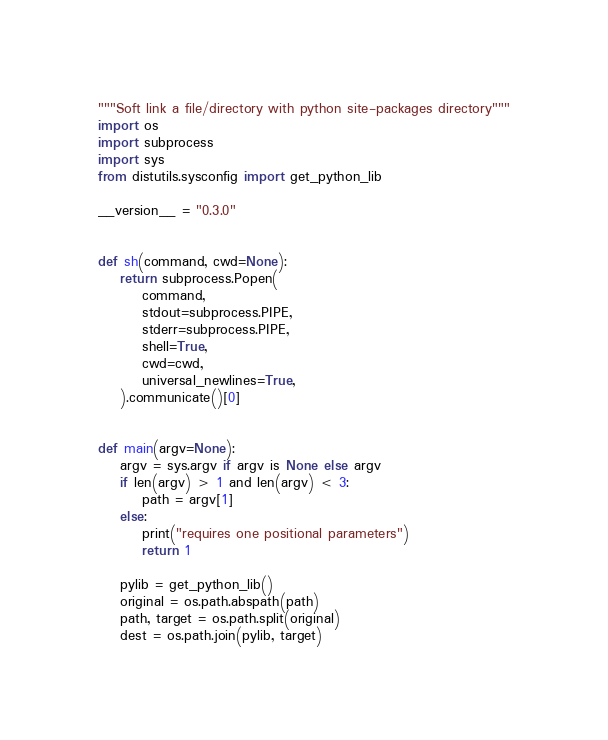<code> <loc_0><loc_0><loc_500><loc_500><_Python_>"""Soft link a file/directory with python site-packages directory"""
import os
import subprocess
import sys
from distutils.sysconfig import get_python_lib

__version__ = "0.3.0"


def sh(command, cwd=None):
    return subprocess.Popen(
        command,
        stdout=subprocess.PIPE,
        stderr=subprocess.PIPE,
        shell=True,
        cwd=cwd,
        universal_newlines=True,
    ).communicate()[0]


def main(argv=None):
    argv = sys.argv if argv is None else argv
    if len(argv) > 1 and len(argv) < 3:
        path = argv[1]
    else:
        print("requires one positional parameters")
        return 1

    pylib = get_python_lib()
    original = os.path.abspath(path)
    path, target = os.path.split(original)
    dest = os.path.join(pylib, target)</code> 